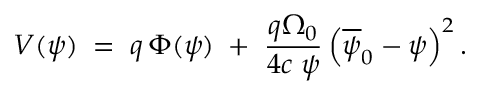Convert formula to latex. <formula><loc_0><loc_0><loc_500><loc_500>V ( \psi ) \, = \, q \, \Phi ( \psi ) \, + \, \frac { q \Omega _ { 0 } } { 4 c \, \psi } \left ( \overline { \psi } _ { 0 } - \psi \right ) ^ { 2 } .</formula> 